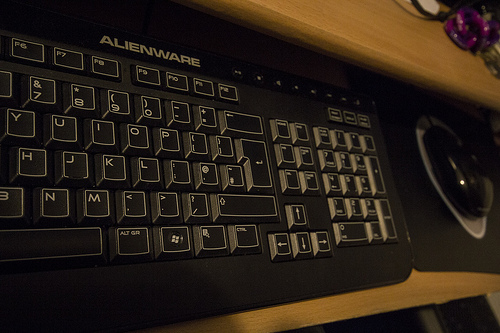Which kind of device is right of the keyboard? Located to the right of the keyboard is a computer mouse, an essential peripheral that allows users to interact seamlessly with their computer interface. 